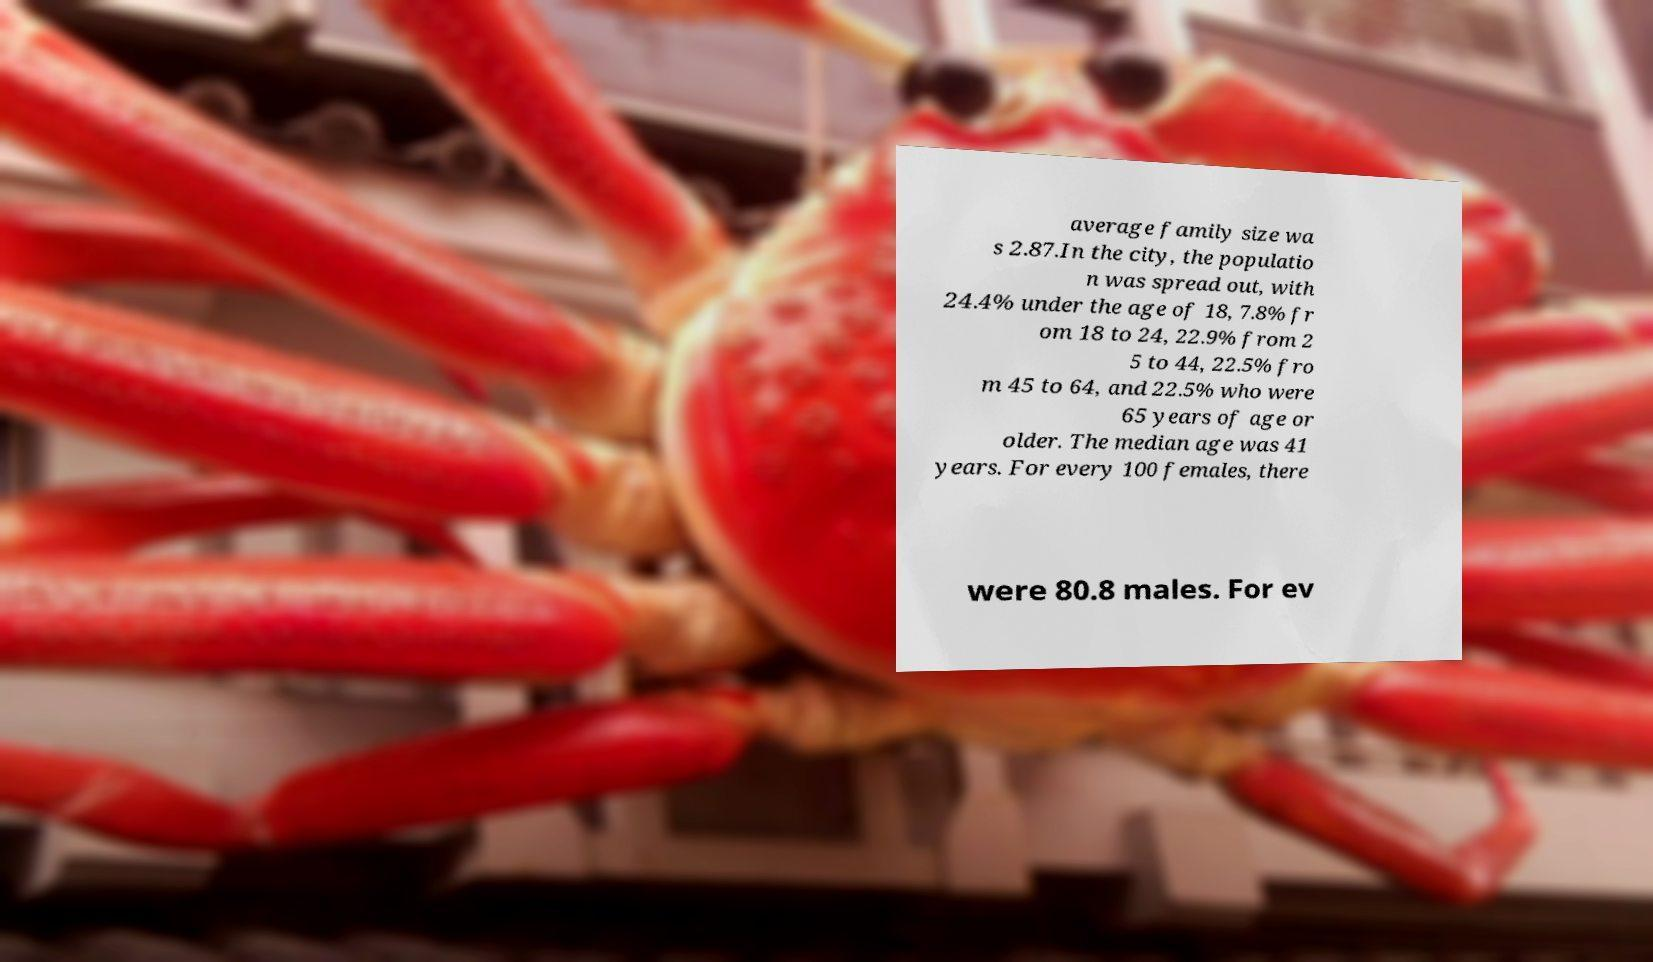Could you extract and type out the text from this image? average family size wa s 2.87.In the city, the populatio n was spread out, with 24.4% under the age of 18, 7.8% fr om 18 to 24, 22.9% from 2 5 to 44, 22.5% fro m 45 to 64, and 22.5% who were 65 years of age or older. The median age was 41 years. For every 100 females, there were 80.8 males. For ev 